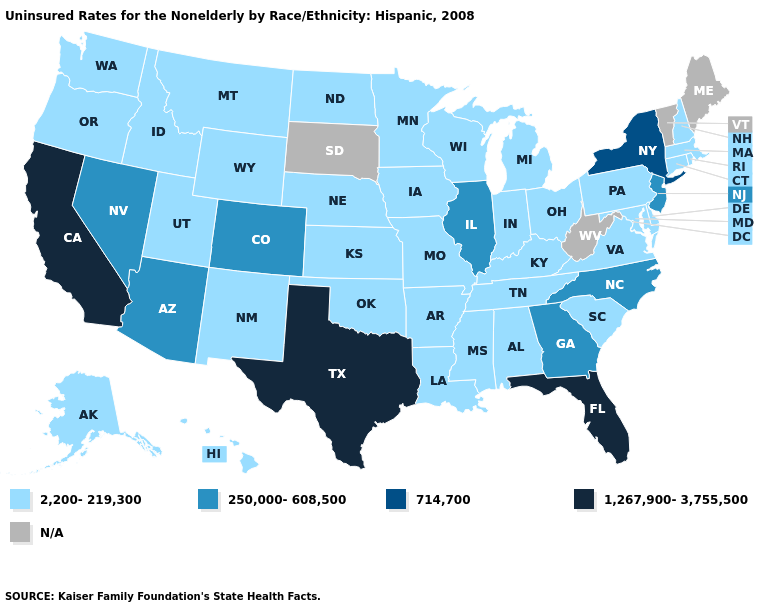Name the states that have a value in the range 1,267,900-3,755,500?
Concise answer only. California, Florida, Texas. Is the legend a continuous bar?
Be succinct. No. Name the states that have a value in the range 2,200-219,300?
Answer briefly. Alabama, Alaska, Arkansas, Connecticut, Delaware, Hawaii, Idaho, Indiana, Iowa, Kansas, Kentucky, Louisiana, Maryland, Massachusetts, Michigan, Minnesota, Mississippi, Missouri, Montana, Nebraska, New Hampshire, New Mexico, North Dakota, Ohio, Oklahoma, Oregon, Pennsylvania, Rhode Island, South Carolina, Tennessee, Utah, Virginia, Washington, Wisconsin, Wyoming. Name the states that have a value in the range 250,000-608,500?
Answer briefly. Arizona, Colorado, Georgia, Illinois, Nevada, New Jersey, North Carolina. Which states have the lowest value in the MidWest?
Give a very brief answer. Indiana, Iowa, Kansas, Michigan, Minnesota, Missouri, Nebraska, North Dakota, Ohio, Wisconsin. Name the states that have a value in the range 2,200-219,300?
Quick response, please. Alabama, Alaska, Arkansas, Connecticut, Delaware, Hawaii, Idaho, Indiana, Iowa, Kansas, Kentucky, Louisiana, Maryland, Massachusetts, Michigan, Minnesota, Mississippi, Missouri, Montana, Nebraska, New Hampshire, New Mexico, North Dakota, Ohio, Oklahoma, Oregon, Pennsylvania, Rhode Island, South Carolina, Tennessee, Utah, Virginia, Washington, Wisconsin, Wyoming. Which states have the lowest value in the USA?
Write a very short answer. Alabama, Alaska, Arkansas, Connecticut, Delaware, Hawaii, Idaho, Indiana, Iowa, Kansas, Kentucky, Louisiana, Maryland, Massachusetts, Michigan, Minnesota, Mississippi, Missouri, Montana, Nebraska, New Hampshire, New Mexico, North Dakota, Ohio, Oklahoma, Oregon, Pennsylvania, Rhode Island, South Carolina, Tennessee, Utah, Virginia, Washington, Wisconsin, Wyoming. Is the legend a continuous bar?
Quick response, please. No. What is the value of Michigan?
Keep it brief. 2,200-219,300. Is the legend a continuous bar?
Concise answer only. No. What is the highest value in the USA?
Short answer required. 1,267,900-3,755,500. What is the value of Connecticut?
Write a very short answer. 2,200-219,300. 